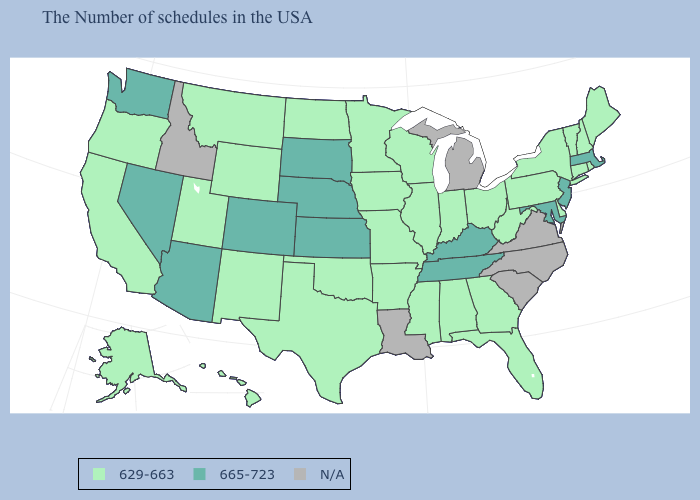Does the first symbol in the legend represent the smallest category?
Give a very brief answer. Yes. Name the states that have a value in the range 629-663?
Be succinct. Maine, Rhode Island, New Hampshire, Vermont, Connecticut, New York, Delaware, Pennsylvania, West Virginia, Ohio, Florida, Georgia, Indiana, Alabama, Wisconsin, Illinois, Mississippi, Missouri, Arkansas, Minnesota, Iowa, Oklahoma, Texas, North Dakota, Wyoming, New Mexico, Utah, Montana, California, Oregon, Alaska, Hawaii. Which states hav the highest value in the West?
Answer briefly. Colorado, Arizona, Nevada, Washington. How many symbols are there in the legend?
Be succinct. 3. Does the first symbol in the legend represent the smallest category?
Quick response, please. Yes. Name the states that have a value in the range 629-663?
Short answer required. Maine, Rhode Island, New Hampshire, Vermont, Connecticut, New York, Delaware, Pennsylvania, West Virginia, Ohio, Florida, Georgia, Indiana, Alabama, Wisconsin, Illinois, Mississippi, Missouri, Arkansas, Minnesota, Iowa, Oklahoma, Texas, North Dakota, Wyoming, New Mexico, Utah, Montana, California, Oregon, Alaska, Hawaii. How many symbols are there in the legend?
Give a very brief answer. 3. Does Wisconsin have the highest value in the USA?
Write a very short answer. No. What is the value of Connecticut?
Quick response, please. 629-663. How many symbols are there in the legend?
Quick response, please. 3. What is the value of Utah?
Keep it brief. 629-663. Name the states that have a value in the range 665-723?
Concise answer only. Massachusetts, New Jersey, Maryland, Kentucky, Tennessee, Kansas, Nebraska, South Dakota, Colorado, Arizona, Nevada, Washington. What is the value of Kansas?
Quick response, please. 665-723. Name the states that have a value in the range 665-723?
Answer briefly. Massachusetts, New Jersey, Maryland, Kentucky, Tennessee, Kansas, Nebraska, South Dakota, Colorado, Arizona, Nevada, Washington. 